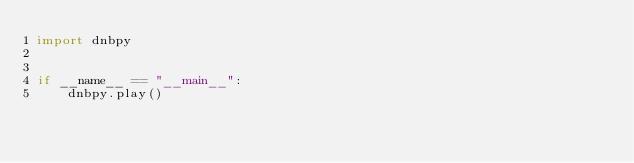<code> <loc_0><loc_0><loc_500><loc_500><_Python_>import dnbpy


if __name__ == "__main__":
    dnbpy.play()
</code> 